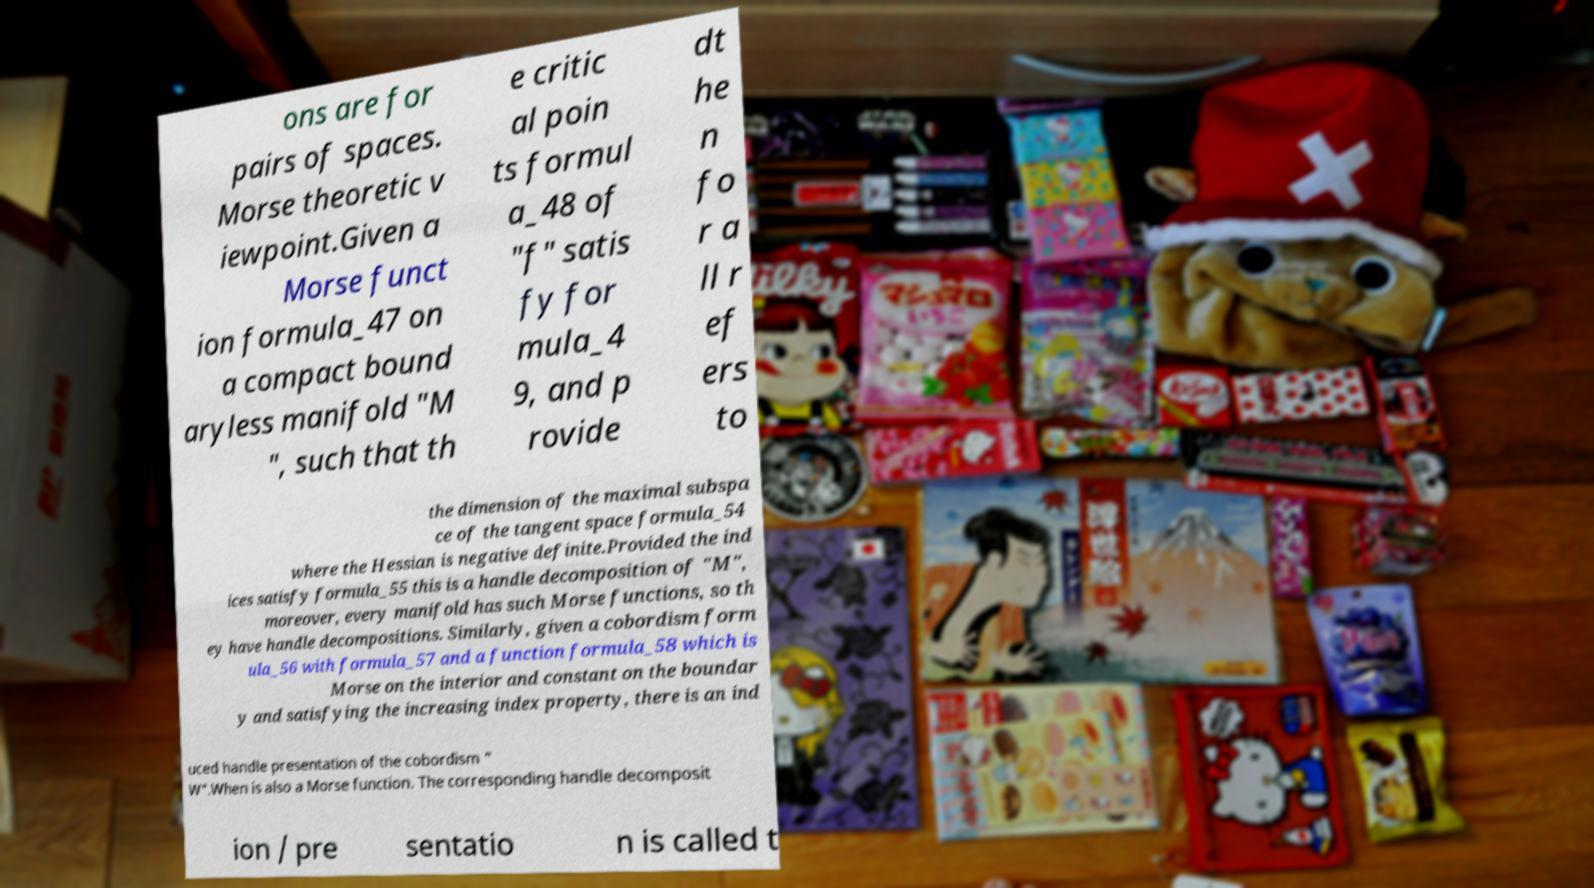What messages or text are displayed in this image? I need them in a readable, typed format. ons are for pairs of spaces. Morse theoretic v iewpoint.Given a Morse funct ion formula_47 on a compact bound aryless manifold "M ", such that th e critic al poin ts formul a_48 of "f" satis fy for mula_4 9, and p rovide dt he n fo r a ll r ef ers to the dimension of the maximal subspa ce of the tangent space formula_54 where the Hessian is negative definite.Provided the ind ices satisfy formula_55 this is a handle decomposition of "M", moreover, every manifold has such Morse functions, so th ey have handle decompositions. Similarly, given a cobordism form ula_56 with formula_57 and a function formula_58 which is Morse on the interior and constant on the boundar y and satisfying the increasing index property, there is an ind uced handle presentation of the cobordism " W".When is also a Morse function. The corresponding handle decomposit ion / pre sentatio n is called t 